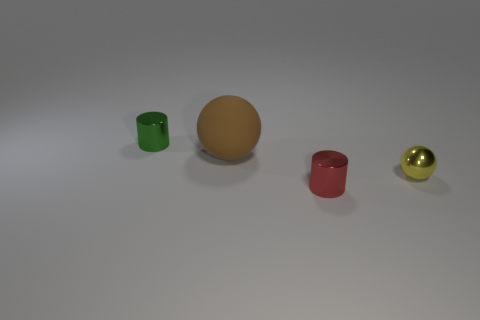There is a tiny object that is both to the left of the yellow metal object and in front of the green object; what material is it made of?
Make the answer very short. Metal. Does the tiny yellow object have the same material as the tiny cylinder that is behind the yellow sphere?
Give a very brief answer. Yes. Is there anything else that is the same size as the red metallic object?
Offer a very short reply. Yes. What number of objects are tiny brown metal spheres or objects that are in front of the tiny green cylinder?
Provide a short and direct response. 3. There is a cylinder on the right side of the tiny green metallic cylinder; is its size the same as the shiny cylinder behind the brown rubber thing?
Offer a very short reply. Yes. There is a brown matte object; is it the same size as the red metal object to the left of the small ball?
Your answer should be very brief. No. There is a metallic object that is on the right side of the thing that is in front of the tiny yellow metallic object; what is its size?
Keep it short and to the point. Small. What is the color of the matte thing that is the same shape as the yellow shiny thing?
Keep it short and to the point. Brown. Is the size of the yellow shiny object the same as the red metallic thing?
Provide a succinct answer. Yes. Is the number of small things in front of the rubber thing the same as the number of big balls?
Your response must be concise. No. 